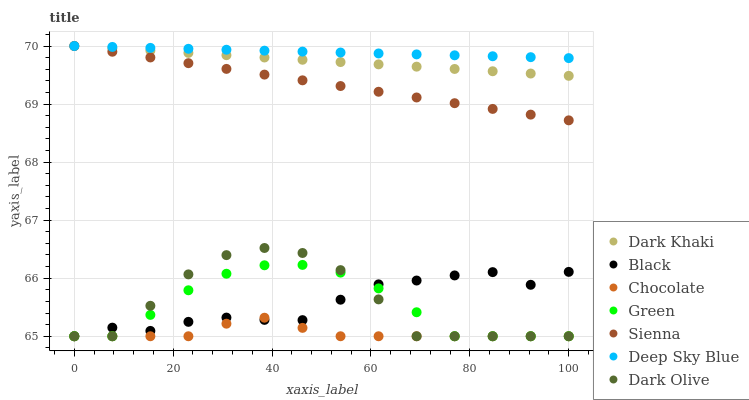Does Chocolate have the minimum area under the curve?
Answer yes or no. Yes. Does Deep Sky Blue have the maximum area under the curve?
Answer yes or no. Yes. Does Dark Olive have the minimum area under the curve?
Answer yes or no. No. Does Dark Olive have the maximum area under the curve?
Answer yes or no. No. Is Deep Sky Blue the smoothest?
Answer yes or no. Yes. Is Dark Olive the roughest?
Answer yes or no. Yes. Is Chocolate the smoothest?
Answer yes or no. No. Is Chocolate the roughest?
Answer yes or no. No. Does Dark Olive have the lowest value?
Answer yes or no. Yes. Does Dark Khaki have the lowest value?
Answer yes or no. No. Does Deep Sky Blue have the highest value?
Answer yes or no. Yes. Does Dark Olive have the highest value?
Answer yes or no. No. Is Black less than Sienna?
Answer yes or no. Yes. Is Dark Khaki greater than Dark Olive?
Answer yes or no. Yes. Does Sienna intersect Dark Khaki?
Answer yes or no. Yes. Is Sienna less than Dark Khaki?
Answer yes or no. No. Is Sienna greater than Dark Khaki?
Answer yes or no. No. Does Black intersect Sienna?
Answer yes or no. No. 